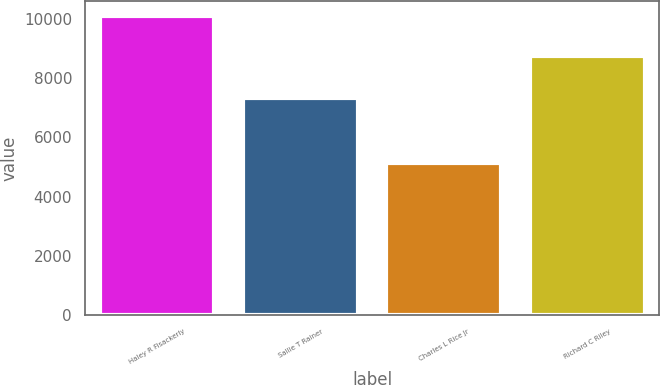<chart> <loc_0><loc_0><loc_500><loc_500><bar_chart><fcel>Haley R Fisackerly<fcel>Sallie T Rainer<fcel>Charles L Rice Jr<fcel>Richard C Riley<nl><fcel>10089<fcel>7320<fcel>5142<fcel>8727<nl></chart> 